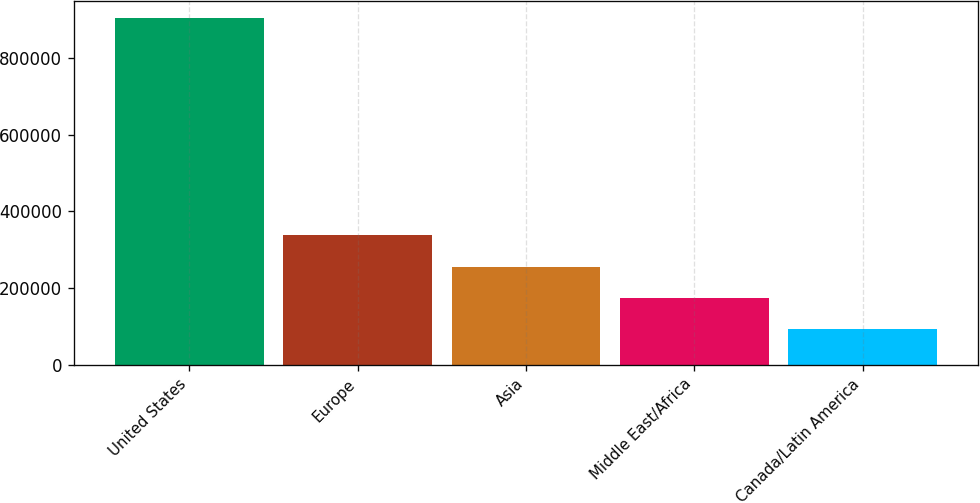Convert chart. <chart><loc_0><loc_0><loc_500><loc_500><bar_chart><fcel>United States<fcel>Europe<fcel>Asia<fcel>Middle East/Africa<fcel>Canada/Latin America<nl><fcel>903582<fcel>338805<fcel>255098<fcel>174038<fcel>92977<nl></chart> 